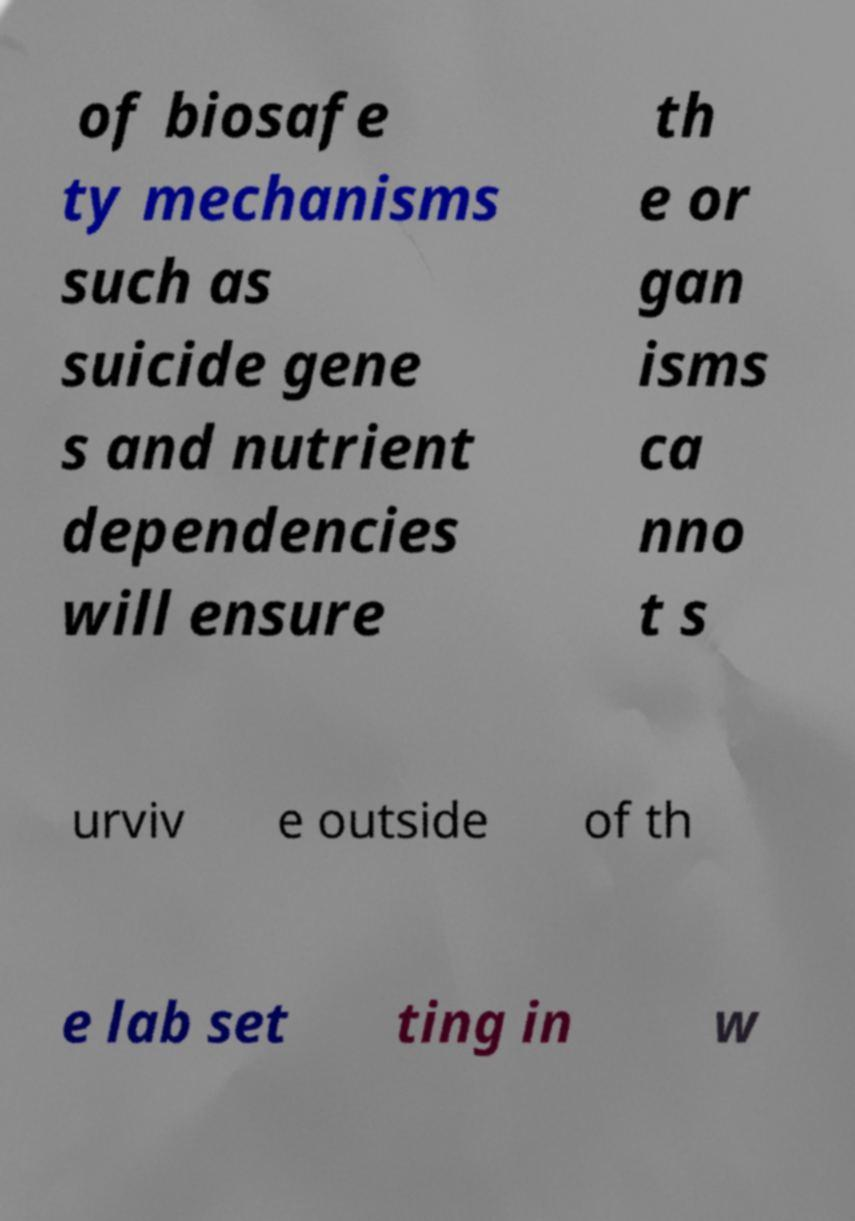Could you assist in decoding the text presented in this image and type it out clearly? of biosafe ty mechanisms such as suicide gene s and nutrient dependencies will ensure th e or gan isms ca nno t s urviv e outside of th e lab set ting in w 